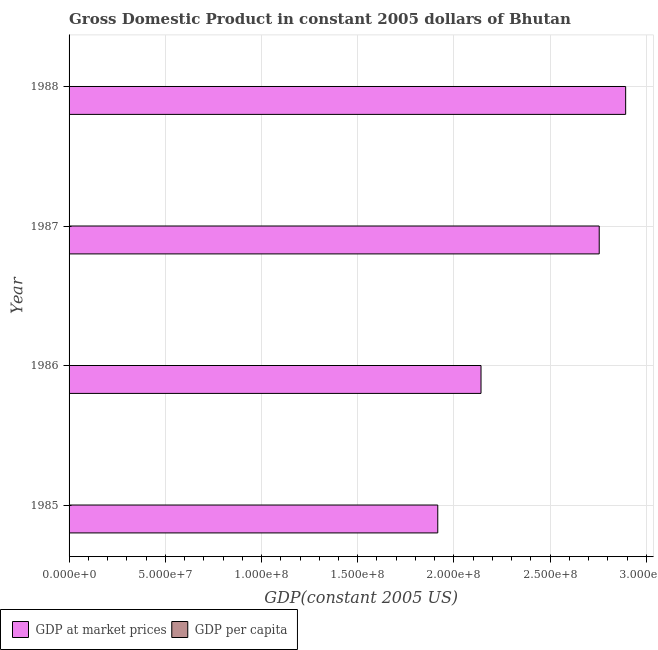Are the number of bars per tick equal to the number of legend labels?
Your answer should be compact. Yes. How many bars are there on the 2nd tick from the top?
Your answer should be compact. 2. How many bars are there on the 4th tick from the bottom?
Your answer should be compact. 2. In how many cases, is the number of bars for a given year not equal to the number of legend labels?
Your answer should be compact. 0. What is the gdp per capita in 1985?
Your response must be concise. 408.5. Across all years, what is the maximum gdp per capita?
Make the answer very short. 559.38. Across all years, what is the minimum gdp per capita?
Provide a short and direct response. 408.5. What is the total gdp per capita in the graph?
Your answer should be very brief. 1959.97. What is the difference between the gdp per capita in 1985 and that in 1988?
Keep it short and to the point. -150.87. What is the difference between the gdp at market prices in 1988 and the gdp per capita in 1986?
Offer a terse response. 2.89e+08. What is the average gdp per capita per year?
Provide a short and direct response. 489.99. In the year 1986, what is the difference between the gdp at market prices and gdp per capita?
Your answer should be compact. 2.14e+08. What is the ratio of the gdp per capita in 1985 to that in 1986?
Your answer should be very brief. 0.92. Is the difference between the gdp per capita in 1987 and 1988 greater than the difference between the gdp at market prices in 1987 and 1988?
Offer a terse response. Yes. What is the difference between the highest and the second highest gdp per capita?
Provide a succinct answer. 9.43. What is the difference between the highest and the lowest gdp per capita?
Your answer should be very brief. 150.87. Is the sum of the gdp per capita in 1986 and 1988 greater than the maximum gdp at market prices across all years?
Provide a succinct answer. No. What does the 2nd bar from the top in 1986 represents?
Keep it short and to the point. GDP at market prices. What does the 2nd bar from the bottom in 1985 represents?
Your answer should be very brief. GDP per capita. What is the difference between two consecutive major ticks on the X-axis?
Keep it short and to the point. 5.00e+07. Are the values on the major ticks of X-axis written in scientific E-notation?
Your answer should be very brief. Yes. What is the title of the graph?
Provide a short and direct response. Gross Domestic Product in constant 2005 dollars of Bhutan. What is the label or title of the X-axis?
Keep it short and to the point. GDP(constant 2005 US). What is the GDP(constant 2005 US) of GDP at market prices in 1985?
Offer a terse response. 1.92e+08. What is the GDP(constant 2005 US) of GDP per capita in 1985?
Offer a very short reply. 408.5. What is the GDP(constant 2005 US) in GDP at market prices in 1986?
Give a very brief answer. 2.14e+08. What is the GDP(constant 2005 US) of GDP per capita in 1986?
Give a very brief answer. 442.15. What is the GDP(constant 2005 US) of GDP at market prices in 1987?
Your answer should be very brief. 2.75e+08. What is the GDP(constant 2005 US) in GDP per capita in 1987?
Your answer should be very brief. 549.94. What is the GDP(constant 2005 US) in GDP at market prices in 1988?
Offer a terse response. 2.89e+08. What is the GDP(constant 2005 US) in GDP per capita in 1988?
Provide a short and direct response. 559.38. Across all years, what is the maximum GDP(constant 2005 US) of GDP at market prices?
Your answer should be very brief. 2.89e+08. Across all years, what is the maximum GDP(constant 2005 US) of GDP per capita?
Keep it short and to the point. 559.38. Across all years, what is the minimum GDP(constant 2005 US) of GDP at market prices?
Your response must be concise. 1.92e+08. Across all years, what is the minimum GDP(constant 2005 US) in GDP per capita?
Your response must be concise. 408.5. What is the total GDP(constant 2005 US) in GDP at market prices in the graph?
Keep it short and to the point. 9.70e+08. What is the total GDP(constant 2005 US) in GDP per capita in the graph?
Offer a very short reply. 1959.97. What is the difference between the GDP(constant 2005 US) of GDP at market prices in 1985 and that in 1986?
Provide a succinct answer. -2.25e+07. What is the difference between the GDP(constant 2005 US) of GDP per capita in 1985 and that in 1986?
Provide a succinct answer. -33.65. What is the difference between the GDP(constant 2005 US) of GDP at market prices in 1985 and that in 1987?
Offer a terse response. -8.39e+07. What is the difference between the GDP(constant 2005 US) in GDP per capita in 1985 and that in 1987?
Provide a short and direct response. -141.44. What is the difference between the GDP(constant 2005 US) in GDP at market prices in 1985 and that in 1988?
Offer a very short reply. -9.76e+07. What is the difference between the GDP(constant 2005 US) in GDP per capita in 1985 and that in 1988?
Offer a terse response. -150.87. What is the difference between the GDP(constant 2005 US) in GDP at market prices in 1986 and that in 1987?
Provide a succinct answer. -6.14e+07. What is the difference between the GDP(constant 2005 US) of GDP per capita in 1986 and that in 1987?
Give a very brief answer. -107.8. What is the difference between the GDP(constant 2005 US) of GDP at market prices in 1986 and that in 1988?
Offer a very short reply. -7.52e+07. What is the difference between the GDP(constant 2005 US) of GDP per capita in 1986 and that in 1988?
Your answer should be very brief. -117.23. What is the difference between the GDP(constant 2005 US) of GDP at market prices in 1987 and that in 1988?
Your response must be concise. -1.37e+07. What is the difference between the GDP(constant 2005 US) in GDP per capita in 1987 and that in 1988?
Your answer should be very brief. -9.43. What is the difference between the GDP(constant 2005 US) in GDP at market prices in 1985 and the GDP(constant 2005 US) in GDP per capita in 1986?
Keep it short and to the point. 1.92e+08. What is the difference between the GDP(constant 2005 US) of GDP at market prices in 1985 and the GDP(constant 2005 US) of GDP per capita in 1987?
Offer a terse response. 1.92e+08. What is the difference between the GDP(constant 2005 US) of GDP at market prices in 1985 and the GDP(constant 2005 US) of GDP per capita in 1988?
Give a very brief answer. 1.92e+08. What is the difference between the GDP(constant 2005 US) in GDP at market prices in 1986 and the GDP(constant 2005 US) in GDP per capita in 1987?
Make the answer very short. 2.14e+08. What is the difference between the GDP(constant 2005 US) in GDP at market prices in 1986 and the GDP(constant 2005 US) in GDP per capita in 1988?
Offer a very short reply. 2.14e+08. What is the difference between the GDP(constant 2005 US) of GDP at market prices in 1987 and the GDP(constant 2005 US) of GDP per capita in 1988?
Ensure brevity in your answer.  2.75e+08. What is the average GDP(constant 2005 US) of GDP at market prices per year?
Your answer should be compact. 2.43e+08. What is the average GDP(constant 2005 US) in GDP per capita per year?
Offer a very short reply. 489.99. In the year 1985, what is the difference between the GDP(constant 2005 US) of GDP at market prices and GDP(constant 2005 US) of GDP per capita?
Your response must be concise. 1.92e+08. In the year 1986, what is the difference between the GDP(constant 2005 US) in GDP at market prices and GDP(constant 2005 US) in GDP per capita?
Provide a succinct answer. 2.14e+08. In the year 1987, what is the difference between the GDP(constant 2005 US) in GDP at market prices and GDP(constant 2005 US) in GDP per capita?
Your answer should be very brief. 2.75e+08. In the year 1988, what is the difference between the GDP(constant 2005 US) in GDP at market prices and GDP(constant 2005 US) in GDP per capita?
Make the answer very short. 2.89e+08. What is the ratio of the GDP(constant 2005 US) of GDP at market prices in 1985 to that in 1986?
Give a very brief answer. 0.9. What is the ratio of the GDP(constant 2005 US) in GDP per capita in 1985 to that in 1986?
Ensure brevity in your answer.  0.92. What is the ratio of the GDP(constant 2005 US) in GDP at market prices in 1985 to that in 1987?
Ensure brevity in your answer.  0.7. What is the ratio of the GDP(constant 2005 US) in GDP per capita in 1985 to that in 1987?
Your answer should be very brief. 0.74. What is the ratio of the GDP(constant 2005 US) in GDP at market prices in 1985 to that in 1988?
Make the answer very short. 0.66. What is the ratio of the GDP(constant 2005 US) of GDP per capita in 1985 to that in 1988?
Give a very brief answer. 0.73. What is the ratio of the GDP(constant 2005 US) in GDP at market prices in 1986 to that in 1987?
Your answer should be compact. 0.78. What is the ratio of the GDP(constant 2005 US) in GDP per capita in 1986 to that in 1987?
Ensure brevity in your answer.  0.8. What is the ratio of the GDP(constant 2005 US) in GDP at market prices in 1986 to that in 1988?
Give a very brief answer. 0.74. What is the ratio of the GDP(constant 2005 US) of GDP per capita in 1986 to that in 1988?
Make the answer very short. 0.79. What is the ratio of the GDP(constant 2005 US) in GDP at market prices in 1987 to that in 1988?
Offer a terse response. 0.95. What is the ratio of the GDP(constant 2005 US) of GDP per capita in 1987 to that in 1988?
Your answer should be compact. 0.98. What is the difference between the highest and the second highest GDP(constant 2005 US) in GDP at market prices?
Give a very brief answer. 1.37e+07. What is the difference between the highest and the second highest GDP(constant 2005 US) of GDP per capita?
Give a very brief answer. 9.43. What is the difference between the highest and the lowest GDP(constant 2005 US) of GDP at market prices?
Provide a short and direct response. 9.76e+07. What is the difference between the highest and the lowest GDP(constant 2005 US) in GDP per capita?
Provide a succinct answer. 150.87. 